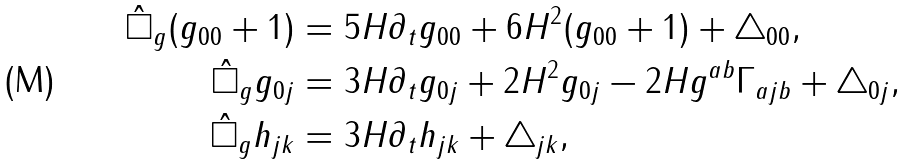Convert formula to latex. <formula><loc_0><loc_0><loc_500><loc_500>\hat { \square } _ { g } ( g _ { 0 0 } + 1 ) & = 5 H \partial _ { t } g _ { 0 0 } + 6 H ^ { 2 } ( g _ { 0 0 } + 1 ) + \triangle _ { 0 0 } , \\ \hat { \square } _ { g } g _ { 0 j } & = 3 H \partial _ { t } g _ { 0 j } + 2 H ^ { 2 } g _ { 0 j } - 2 H g ^ { a b } \Gamma _ { a j b } + \triangle _ { 0 j } , \\ \hat { \square } _ { g } h _ { j k } & = 3 H \partial _ { t } h _ { j k } + \triangle _ { j k } ,</formula> 